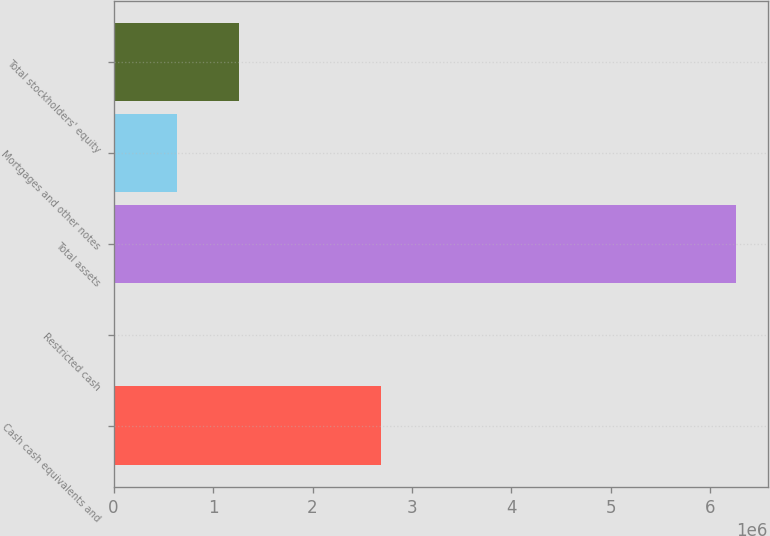<chart> <loc_0><loc_0><loc_500><loc_500><bar_chart><fcel>Cash cash equivalents and<fcel>Restricted cash<fcel>Total assets<fcel>Mortgages and other notes<fcel>Total stockholders' equity<nl><fcel>2.687e+06<fcel>9972<fcel>6.26058e+06<fcel>635033<fcel>1.26009e+06<nl></chart> 